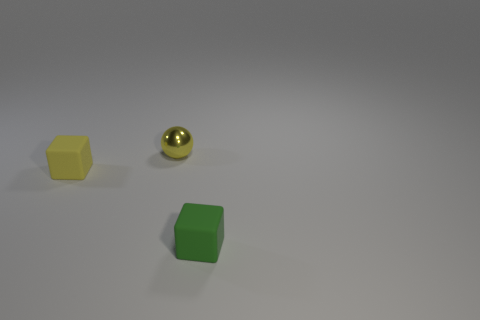Is there anything else of the same color as the tiny shiny object?
Your response must be concise. Yes. Does the small sphere have the same material as the tiny block in front of the yellow rubber block?
Make the answer very short. No. Are there any other things that are the same material as the yellow sphere?
Keep it short and to the point. No. Is the material of the block that is left of the small green thing the same as the tiny yellow object behind the small yellow block?
Ensure brevity in your answer.  No. There is a small rubber cube in front of the yellow thing that is in front of the small metal object behind the small yellow matte object; what color is it?
Make the answer very short. Green. How many other things are the same shape as the yellow metallic thing?
Offer a very short reply. 0. What number of objects are big purple cylinders or yellow things left of the metallic thing?
Your response must be concise. 1. Is there a yellow matte thing that has the same size as the green object?
Ensure brevity in your answer.  Yes. Is the yellow sphere made of the same material as the green cube?
Your response must be concise. No. How many objects are small green matte cubes or small yellow metal objects?
Offer a very short reply. 2. 